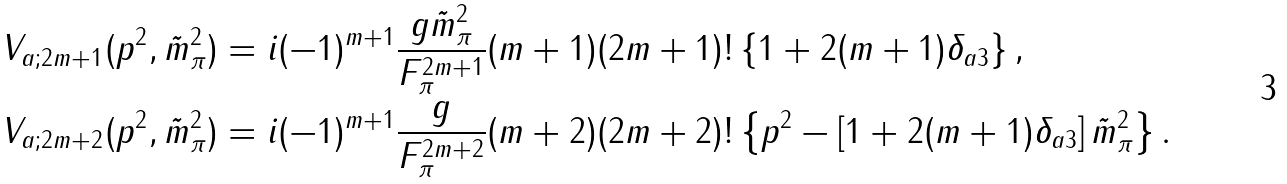<formula> <loc_0><loc_0><loc_500><loc_500>V _ { a ; 2 m + 1 } ( p ^ { 2 } , \tilde { m } ^ { 2 } _ { \pi } ) & = i ( - 1 ) ^ { m + 1 } \frac { g \tilde { m } ^ { 2 } _ { \pi } } { F ^ { 2 m + 1 } _ { \pi } } ( m + 1 ) ( 2 m + 1 ) ! \left \{ 1 + 2 ( m + 1 ) \delta _ { a 3 } \right \} , \\ V _ { a ; 2 m + 2 } ( p ^ { 2 } , \tilde { m } ^ { 2 } _ { \pi } ) & = i ( - 1 ) ^ { m + 1 } \frac { g } { F ^ { 2 m + 2 } _ { \pi } } ( m + 2 ) ( 2 m + 2 ) ! \left \{ p ^ { 2 } - \left [ 1 + 2 ( m + 1 ) \delta _ { a 3 } \right ] \tilde { m } ^ { 2 } _ { \pi } \right \} .</formula> 